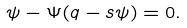Convert formula to latex. <formula><loc_0><loc_0><loc_500><loc_500>\psi - \Psi ( q - s \psi ) = 0 .</formula> 